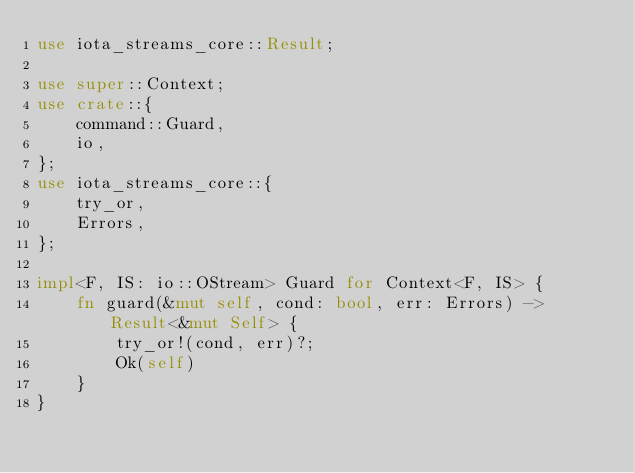Convert code to text. <code><loc_0><loc_0><loc_500><loc_500><_Rust_>use iota_streams_core::Result;

use super::Context;
use crate::{
    command::Guard,
    io,
};
use iota_streams_core::{
    try_or,
    Errors,
};

impl<F, IS: io::OStream> Guard for Context<F, IS> {
    fn guard(&mut self, cond: bool, err: Errors) -> Result<&mut Self> {
        try_or!(cond, err)?;
        Ok(self)
    }
}
</code> 